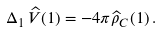<formula> <loc_0><loc_0><loc_500><loc_500>\Delta _ { 1 } \, \widehat { V } ( 1 ) = - 4 \pi \widehat { \rho } _ { C } ( 1 ) \, .</formula> 